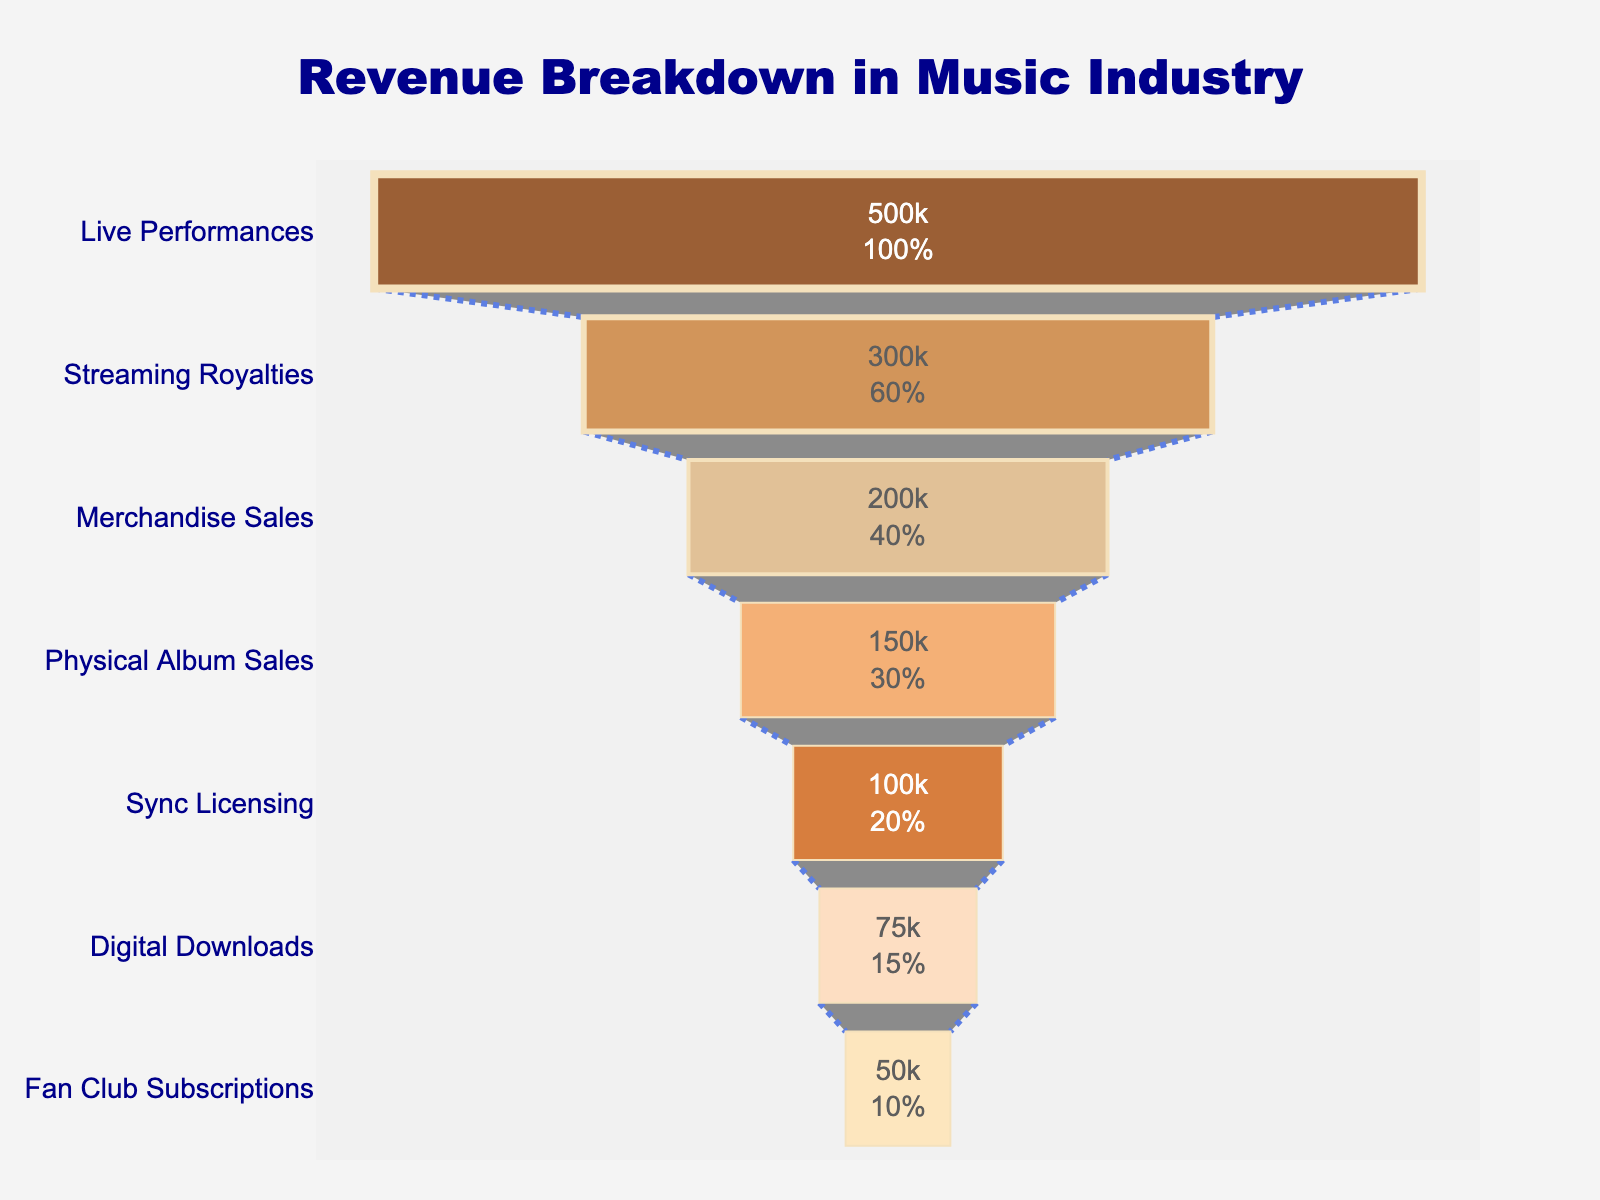what's the title of the figure? The title is written at the top center of the figure. It reads "Revenue Breakdown in Music Industry."
Answer: Revenue Breakdown in Music Industry how is the color scheme of the income streams arranged? The income streams use shades of brown and orange arranged from darkest at the top to lightest at the bottom.
Answer: darkest to lightest: brown to orange which income stream generates the most revenue? The live performances section at the top of the funnel has the highest value.
Answer: Live Performances what's the revenue for merchandise sales? Look for the Merchandise Sales segment in the funnel and read the value inside it.
Answer: 200000 how much more revenue does live performances generate compared to digital downloads? Find the revenue for Live Performances and Digital Downloads and subtract the latter from the former: 500000 - 75000.
Answer: 425000 which income streams together contribute less revenue than streaming royalties? Look for the streams with values that sum up to less than Streaming Royalties (300000). Physical Album Sales, Sync Licensing, Digital Downloads, and Fan Club Subscriptions combined generate less: 150000 + 100000 + 75000 + 50000 = 375000. This is incorrect, better approach: combine smallest streams that meet criteria: Physical Album Sales + Sync Licensing + Digital Downloads + Fan Club Subscriptions (150000 + 100000 + 75000 + 50000 = 375000)
Answer: Digital Downloads + Fan Club Subscriptions how many income streams are represented in the figure? Count the number of distinct segments in the funnel chart.
Answer: 7 how does the revenue from physical album sales compare to merchandise sales? Compare the revenue values for Physical Album Sales and Merchandise Sales. Physical Album Sales generate 150000, whereas Merchandise Sales generate 200000. Merchandise Sales generate more.
Answer: Merchandise Sales generate more if you exclude live performances, what's the average revenue from the remaining income streams? Sum the revenue of the remaining streams and divide by the number of those streams: (300000 + 200000 + 150000 + 100000 + 75000 + 50000) / 6. This equals 875000 / 6.
Answer: 145833.33 what's the percentage contribution of live performances to the total revenue? Calculate the total revenue by summing all revenues, then divide Live Performances revenue by this total and multiply by 100. Total = 500000 + 300000 + 200000 + 150000 + 100000 + 75000 + 50000 = 1375000; Percentage = (500000 / 1375000) * 100.
Answer: 36.36 